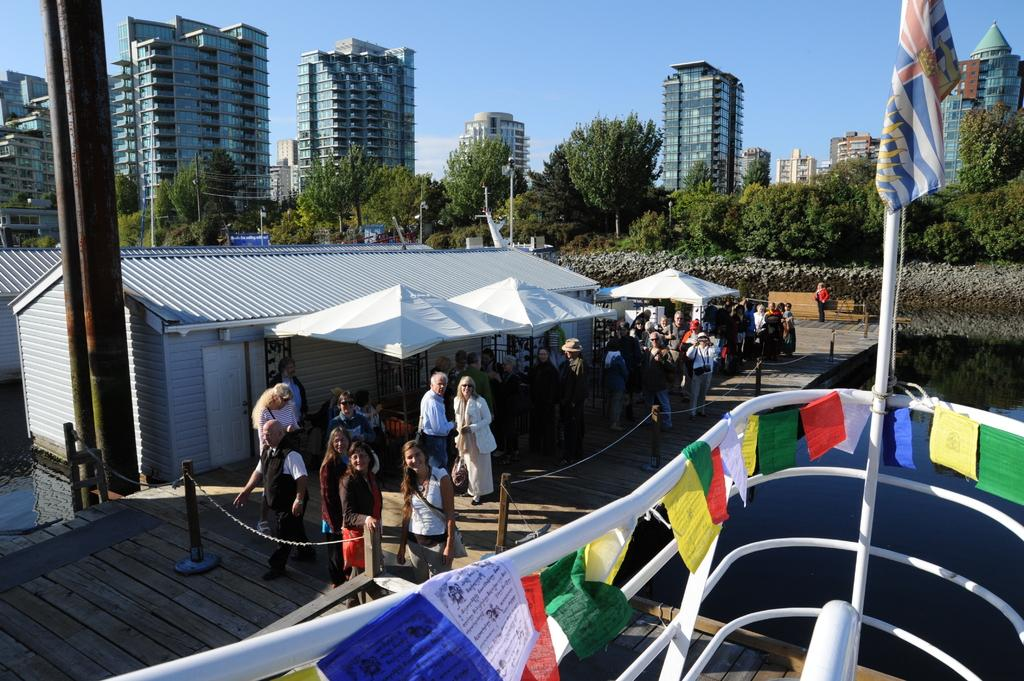What can be seen in the image that people walk on? There is a path in the image that people walk on. Who is present on the path? There are people on the path. What type of temporary shelters can be seen in the image? There are tents in the image. What type of permanent structures can be seen in the image? There are houses in the image. What can be seen in the background of the image? There are trees, buildings, and the sky visible in the background of the image. What is located on the right side of the image? There is a ship on the water on the right side of the image. What type of dress is being worn by the rainstorm in the image? There is no rainstorm present in the image, and therefore no dress can be associated with it. What type of line is connecting the trees in the image? There is no line connecting the trees in the image; they are separate entities. 